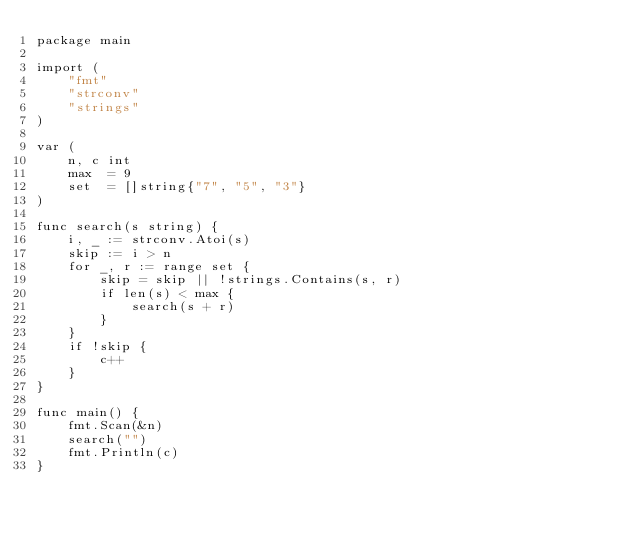Convert code to text. <code><loc_0><loc_0><loc_500><loc_500><_Go_>package main

import (
	"fmt"
	"strconv"
	"strings"
)

var (
	n, c int
	max  = 9
	set  = []string{"7", "5", "3"}
)

func search(s string) {
	i, _ := strconv.Atoi(s)
	skip := i > n
	for _, r := range set {
		skip = skip || !strings.Contains(s, r)
		if len(s) < max {
			search(s + r)
		}
	}
	if !skip {
		c++
	}
}

func main() {
	fmt.Scan(&n)
	search("")
	fmt.Println(c)
}</code> 